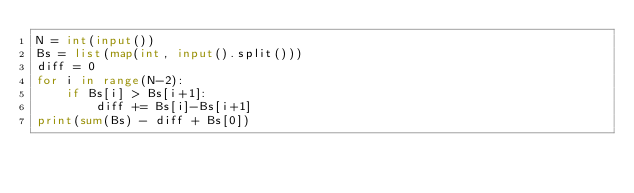<code> <loc_0><loc_0><loc_500><loc_500><_Python_>N = int(input())
Bs = list(map(int, input().split()))
diff = 0
for i in range(N-2):
    if Bs[i] > Bs[i+1]:
        diff += Bs[i]-Bs[i+1]
print(sum(Bs) - diff + Bs[0])</code> 